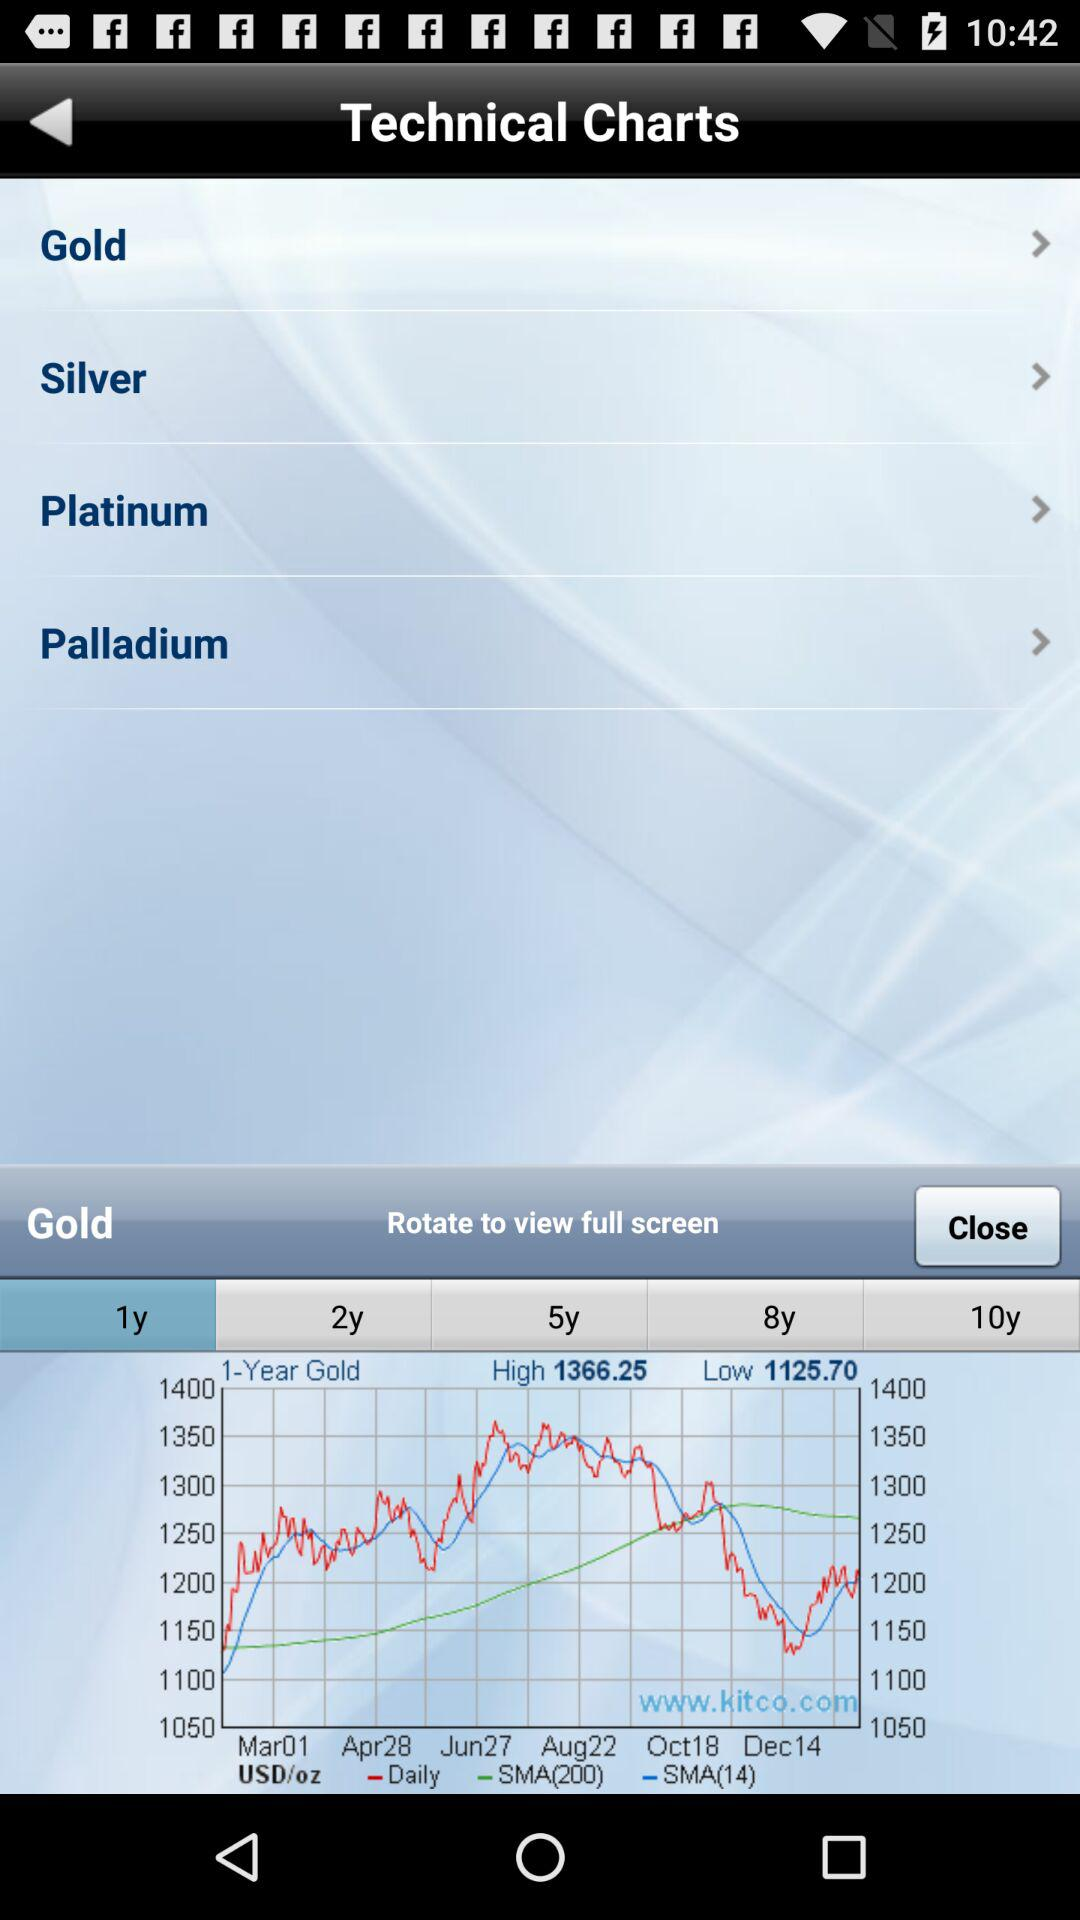What month's data is given on the graph? The months are March, April, June, August, October, and December. 